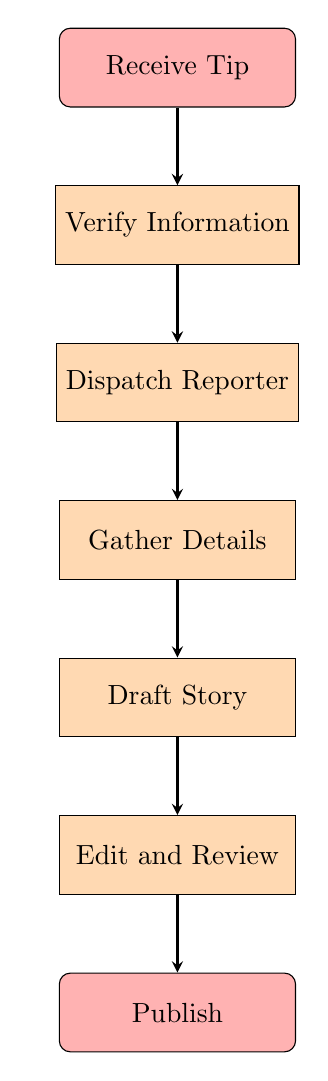What's the first step in the flow chart? The first step in the flow chart is the "Receive Tip," which is located at the top of the diagram.
Answer: Receive Tip How many nodes are in the flow chart? By counting the individual steps represented as nodes in the diagram, there are seven distinct nodes.
Answer: Seven What is the final action in the process? The final action in the flow chart is "Publish," which is the last node at the bottom of the diagram.
Answer: Publish Which step follows "Gather Details"? In the flow chart, the step following "Gather Details" is "Draft Story," as indicated by the arrow connecting these two nodes.
Answer: Draft Story What is the relationship between "Verify Information" and "Dispatch Reporter"? The relationship is sequential, where "Verify Information" must be completed before moving on to "Dispatch Reporter," as represented by the arrow from the first to the second step.
Answer: Sequential What action precedes the "Edit and Review" step? The action that precedes "Edit and Review" is "Draft Story," which is done immediately before the editing process.
Answer: Draft Story Which steps are involved in the reporting process? The steps involved from start to finish are: "Receive Tip," "Verify Information," "Dispatch Reporter," "Gather Details," "Draft Story," "Edit and Review," and "Publish."
Answer: All steps How does the flow begin in the breaking news reporting process? The flow begins with receiving a tip, which sets off the entire process of reporting a breaking news story.
Answer: Receiving a tip What is the purpose of the "Verify Information" step? The purpose of "Verify Information" is to confirm the accuracy of the received tip with trusted sources, ensuring the information is credible before proceeding.
Answer: Credibility check 